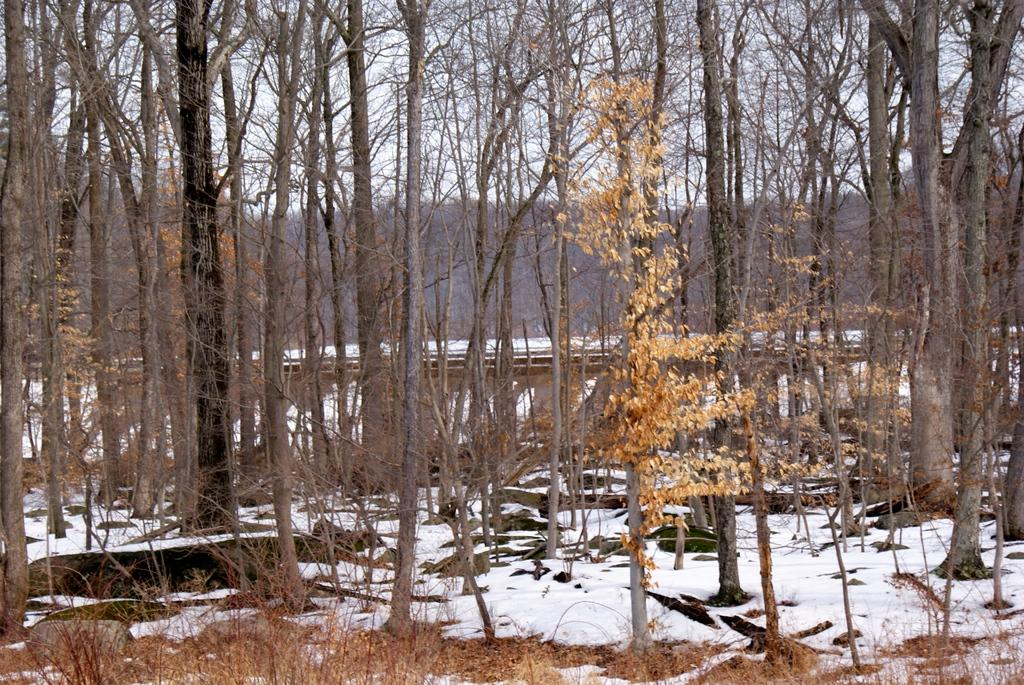What is the condition of the land in the image? The land in the image is covered with snow. What type of vegetation can be seen in the image? There are trees in the image. What type of soup is being served in the image? There is no soup present in the image; it features snow-covered land and trees. Can you see a key hanging from one of the trees in the image? There is no key visible in the image; it only shows snow-covered land and trees. 